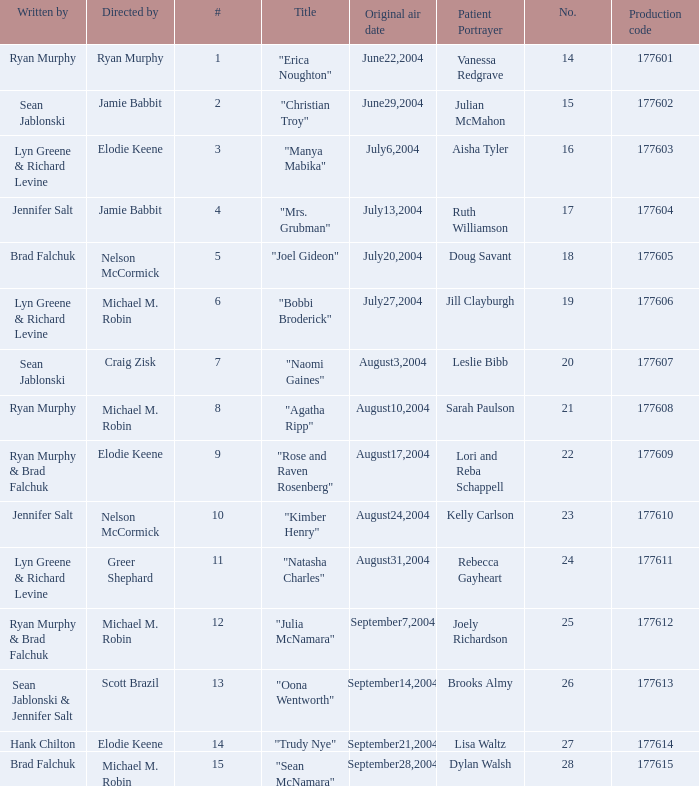What is the highest numbered episode with patient portrayer doug savant? 5.0. 